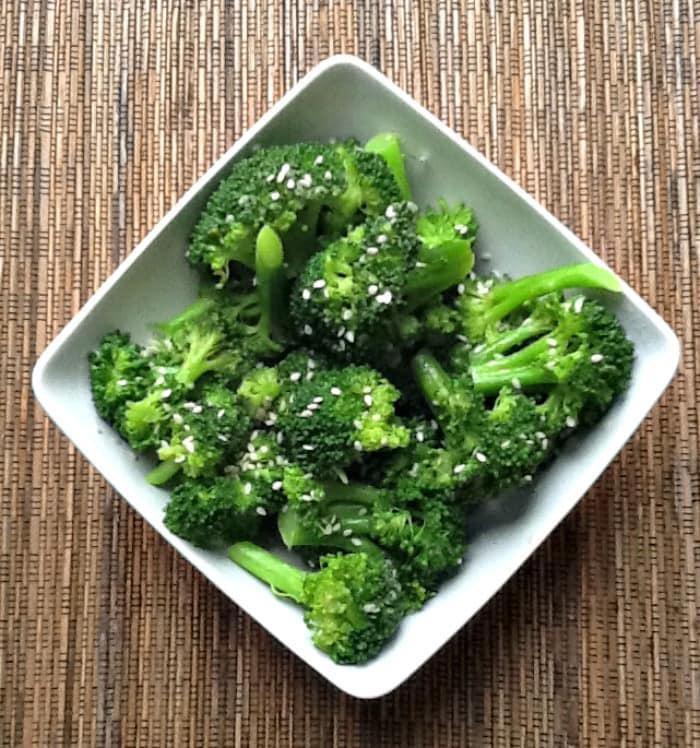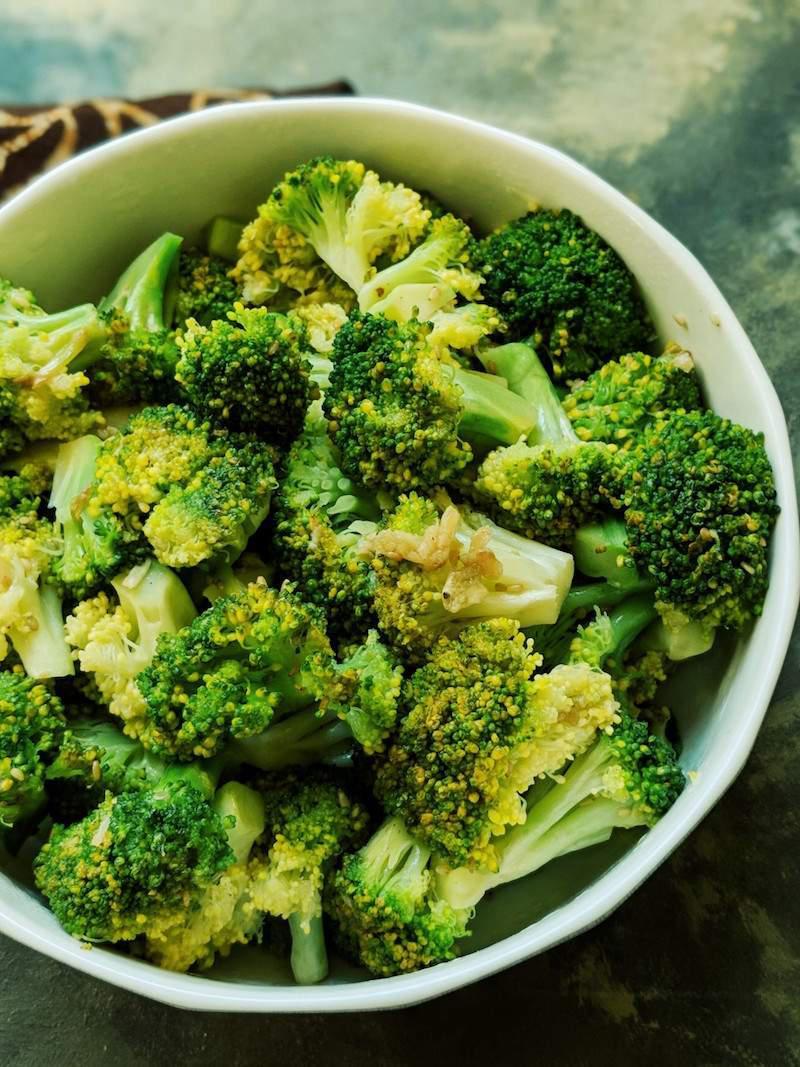The first image is the image on the left, the second image is the image on the right. Considering the images on both sides, is "The left and right image contains the same number of white bowls with broccoli." valid? Answer yes or no. Yes. The first image is the image on the left, the second image is the image on the right. Evaluate the accuracy of this statement regarding the images: "There are two white bowls.". Is it true? Answer yes or no. Yes. 